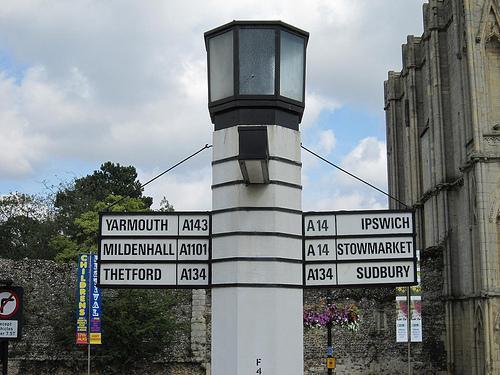How many signs?
Give a very brief answer. 6. 